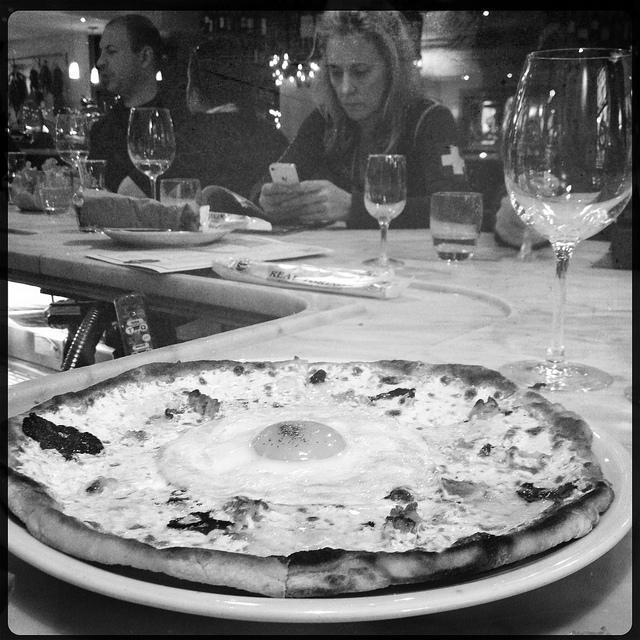How many people are there?
Give a very brief answer. 3. How many cups are there?
Give a very brief answer. 2. How many wine glasses are there?
Give a very brief answer. 3. How many donuts have a pumpkin face?
Give a very brief answer. 0. 